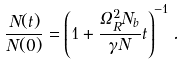<formula> <loc_0><loc_0><loc_500><loc_500>\frac { N ( t ) } { N ( 0 ) } = \left ( 1 + \frac { \Omega _ { R } ^ { 2 } N _ { b } } { \gamma N } t \right ) ^ { - 1 } .</formula> 